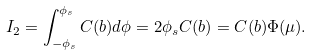Convert formula to latex. <formula><loc_0><loc_0><loc_500><loc_500>I _ { 2 } = \int _ { - \phi _ { s } } ^ { \phi _ { s } } C ( b ) d \phi = 2 \phi _ { s } C ( b ) = C ( b ) \Phi ( \mu ) .</formula> 